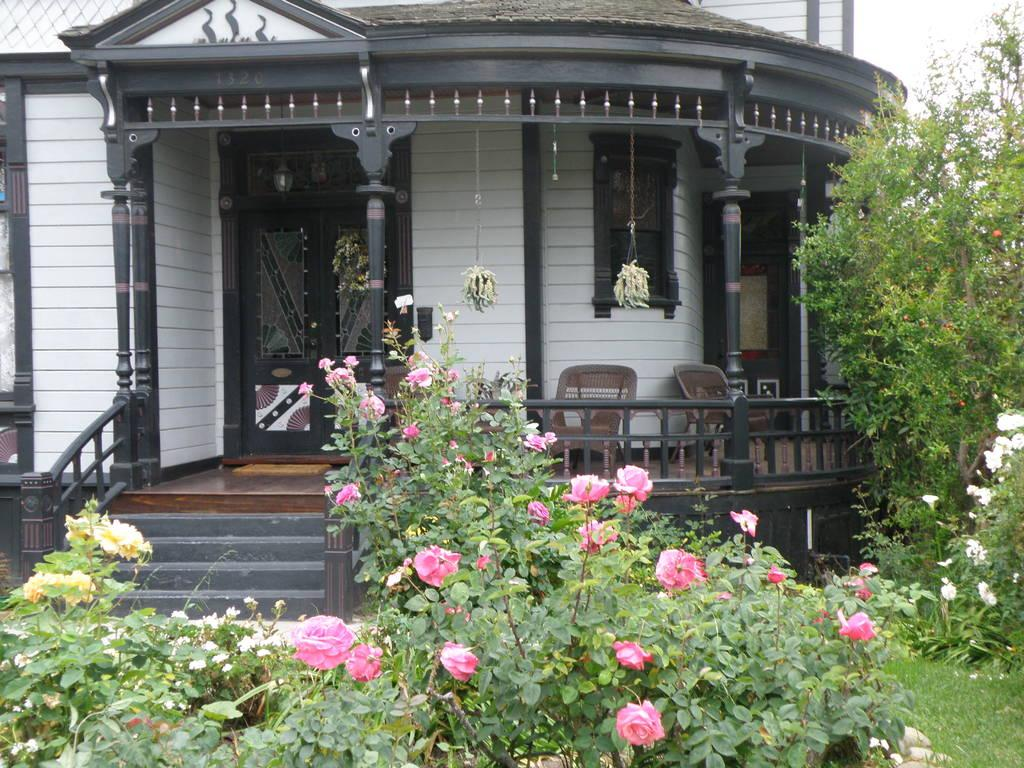What is located in the center of the image? There are trees in the center of the image. What types of vegetation can be seen in the image? There are plants, grass, and flowers in different colors in the image. What type of structure is present in the image? There is a building in the image. What architectural features can be seen in the image? There are poles, windows, fences, a door, and a staircase in the image. What type of cushion is being used for writing in the image? There is no cushion or writing activity present in the image. What operation is being performed on the building in the image? There is no operation being performed on the building in the image; it appears to be a static structure. 